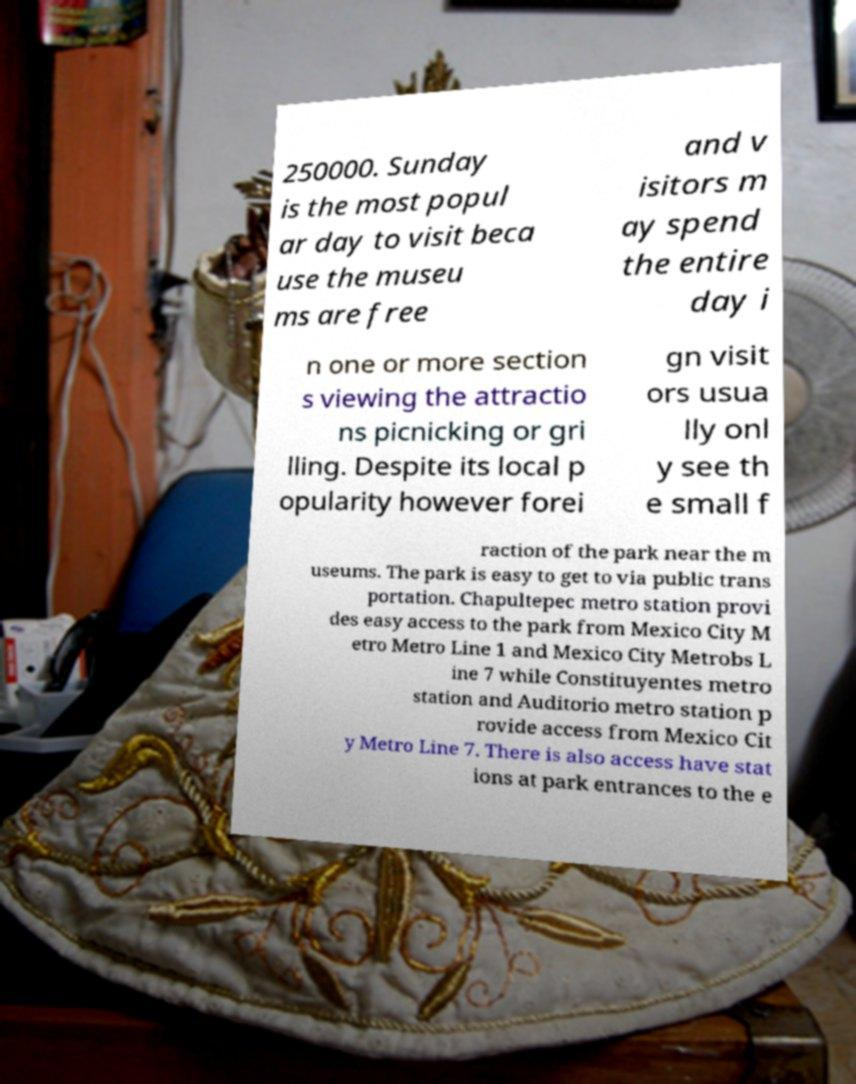I need the written content from this picture converted into text. Can you do that? 250000. Sunday is the most popul ar day to visit beca use the museu ms are free and v isitors m ay spend the entire day i n one or more section s viewing the attractio ns picnicking or gri lling. Despite its local p opularity however forei gn visit ors usua lly onl y see th e small f raction of the park near the m useums. The park is easy to get to via public trans portation. Chapultepec metro station provi des easy access to the park from Mexico City M etro Metro Line 1 and Mexico City Metrobs L ine 7 while Constituyentes metro station and Auditorio metro station p rovide access from Mexico Cit y Metro Line 7. There is also access have stat ions at park entrances to the e 